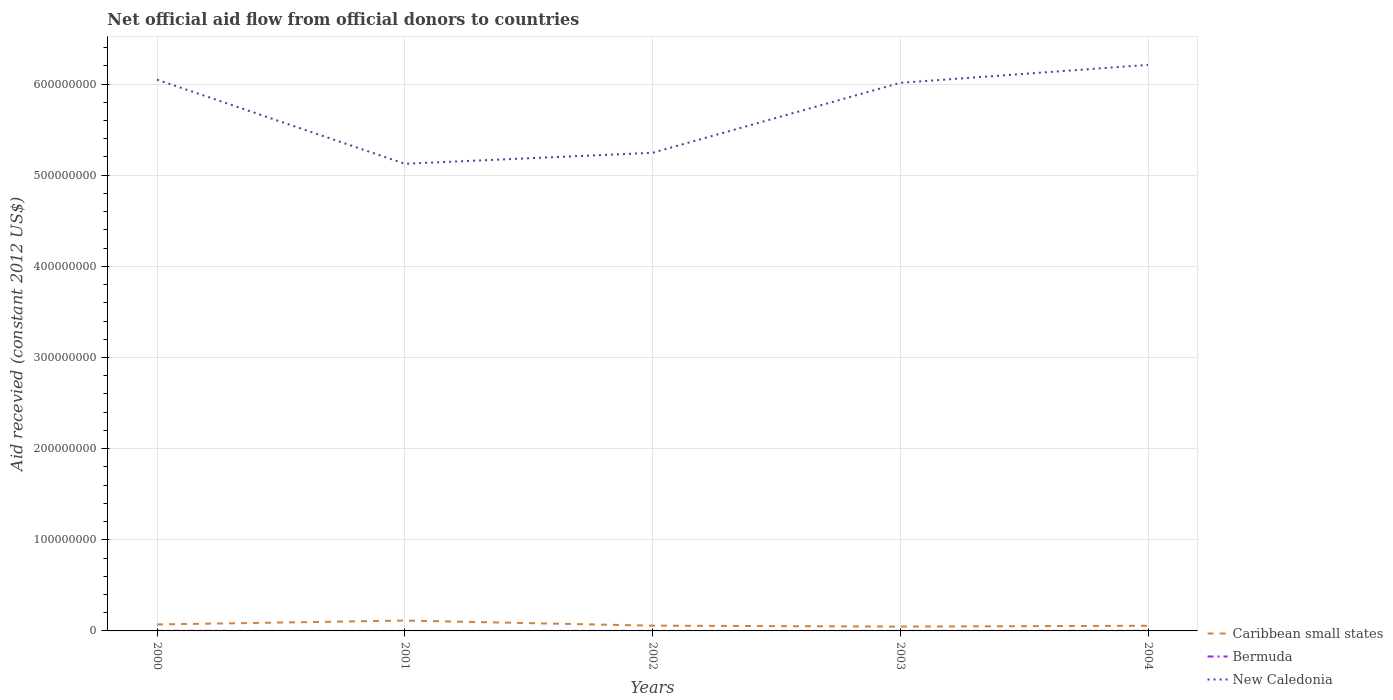Is the number of lines equal to the number of legend labels?
Give a very brief answer. Yes. Across all years, what is the maximum total aid received in Bermuda?
Give a very brief answer. 3.00e+04. What is the total total aid received in Bermuda in the graph?
Offer a very short reply. -8.00e+04. What is the difference between the highest and the second highest total aid received in Caribbean small states?
Ensure brevity in your answer.  6.62e+06. What is the difference between the highest and the lowest total aid received in Caribbean small states?
Offer a very short reply. 2. How many lines are there?
Ensure brevity in your answer.  3. Where does the legend appear in the graph?
Offer a terse response. Bottom right. How many legend labels are there?
Your response must be concise. 3. How are the legend labels stacked?
Provide a short and direct response. Vertical. What is the title of the graph?
Keep it short and to the point. Net official aid flow from official donors to countries. What is the label or title of the X-axis?
Ensure brevity in your answer.  Years. What is the label or title of the Y-axis?
Ensure brevity in your answer.  Aid recevied (constant 2012 US$). What is the Aid recevied (constant 2012 US$) in Caribbean small states in 2000?
Provide a succinct answer. 7.08e+06. What is the Aid recevied (constant 2012 US$) of New Caledonia in 2000?
Keep it short and to the point. 6.05e+08. What is the Aid recevied (constant 2012 US$) of Caribbean small states in 2001?
Ensure brevity in your answer.  1.14e+07. What is the Aid recevied (constant 2012 US$) of New Caledonia in 2001?
Make the answer very short. 5.13e+08. What is the Aid recevied (constant 2012 US$) in Caribbean small states in 2002?
Give a very brief answer. 5.78e+06. What is the Aid recevied (constant 2012 US$) in New Caledonia in 2002?
Provide a short and direct response. 5.25e+08. What is the Aid recevied (constant 2012 US$) in Caribbean small states in 2003?
Ensure brevity in your answer.  4.76e+06. What is the Aid recevied (constant 2012 US$) of New Caledonia in 2003?
Give a very brief answer. 6.01e+08. What is the Aid recevied (constant 2012 US$) in Caribbean small states in 2004?
Make the answer very short. 5.66e+06. What is the Aid recevied (constant 2012 US$) in Bermuda in 2004?
Give a very brief answer. 1.10e+05. What is the Aid recevied (constant 2012 US$) in New Caledonia in 2004?
Offer a very short reply. 6.21e+08. Across all years, what is the maximum Aid recevied (constant 2012 US$) in Caribbean small states?
Your response must be concise. 1.14e+07. Across all years, what is the maximum Aid recevied (constant 2012 US$) of New Caledonia?
Keep it short and to the point. 6.21e+08. Across all years, what is the minimum Aid recevied (constant 2012 US$) in Caribbean small states?
Provide a short and direct response. 4.76e+06. Across all years, what is the minimum Aid recevied (constant 2012 US$) of Bermuda?
Keep it short and to the point. 3.00e+04. Across all years, what is the minimum Aid recevied (constant 2012 US$) in New Caledonia?
Your answer should be very brief. 5.13e+08. What is the total Aid recevied (constant 2012 US$) of Caribbean small states in the graph?
Keep it short and to the point. 3.47e+07. What is the total Aid recevied (constant 2012 US$) in New Caledonia in the graph?
Make the answer very short. 2.86e+09. What is the difference between the Aid recevied (constant 2012 US$) of Caribbean small states in 2000 and that in 2001?
Give a very brief answer. -4.30e+06. What is the difference between the Aid recevied (constant 2012 US$) in New Caledonia in 2000 and that in 2001?
Provide a short and direct response. 9.23e+07. What is the difference between the Aid recevied (constant 2012 US$) in Caribbean small states in 2000 and that in 2002?
Ensure brevity in your answer.  1.30e+06. What is the difference between the Aid recevied (constant 2012 US$) in Bermuda in 2000 and that in 2002?
Make the answer very short. 8.00e+04. What is the difference between the Aid recevied (constant 2012 US$) of New Caledonia in 2000 and that in 2002?
Your answer should be compact. 8.02e+07. What is the difference between the Aid recevied (constant 2012 US$) of Caribbean small states in 2000 and that in 2003?
Provide a succinct answer. 2.32e+06. What is the difference between the Aid recevied (constant 2012 US$) in New Caledonia in 2000 and that in 2003?
Give a very brief answer. 3.50e+06. What is the difference between the Aid recevied (constant 2012 US$) of Caribbean small states in 2000 and that in 2004?
Offer a very short reply. 1.42e+06. What is the difference between the Aid recevied (constant 2012 US$) of Bermuda in 2000 and that in 2004?
Provide a short and direct response. 0. What is the difference between the Aid recevied (constant 2012 US$) in New Caledonia in 2000 and that in 2004?
Provide a short and direct response. -1.62e+07. What is the difference between the Aid recevied (constant 2012 US$) of Caribbean small states in 2001 and that in 2002?
Keep it short and to the point. 5.60e+06. What is the difference between the Aid recevied (constant 2012 US$) in Bermuda in 2001 and that in 2002?
Your answer should be very brief. 10000. What is the difference between the Aid recevied (constant 2012 US$) in New Caledonia in 2001 and that in 2002?
Offer a very short reply. -1.21e+07. What is the difference between the Aid recevied (constant 2012 US$) of Caribbean small states in 2001 and that in 2003?
Ensure brevity in your answer.  6.62e+06. What is the difference between the Aid recevied (constant 2012 US$) of New Caledonia in 2001 and that in 2003?
Provide a succinct answer. -8.88e+07. What is the difference between the Aid recevied (constant 2012 US$) of Caribbean small states in 2001 and that in 2004?
Offer a terse response. 5.72e+06. What is the difference between the Aid recevied (constant 2012 US$) of Bermuda in 2001 and that in 2004?
Offer a very short reply. -7.00e+04. What is the difference between the Aid recevied (constant 2012 US$) of New Caledonia in 2001 and that in 2004?
Give a very brief answer. -1.08e+08. What is the difference between the Aid recevied (constant 2012 US$) of Caribbean small states in 2002 and that in 2003?
Offer a terse response. 1.02e+06. What is the difference between the Aid recevied (constant 2012 US$) of New Caledonia in 2002 and that in 2003?
Keep it short and to the point. -7.67e+07. What is the difference between the Aid recevied (constant 2012 US$) of New Caledonia in 2002 and that in 2004?
Provide a succinct answer. -9.64e+07. What is the difference between the Aid recevied (constant 2012 US$) of Caribbean small states in 2003 and that in 2004?
Provide a short and direct response. -9.00e+05. What is the difference between the Aid recevied (constant 2012 US$) in New Caledonia in 2003 and that in 2004?
Give a very brief answer. -1.97e+07. What is the difference between the Aid recevied (constant 2012 US$) in Caribbean small states in 2000 and the Aid recevied (constant 2012 US$) in Bermuda in 2001?
Provide a short and direct response. 7.04e+06. What is the difference between the Aid recevied (constant 2012 US$) of Caribbean small states in 2000 and the Aid recevied (constant 2012 US$) of New Caledonia in 2001?
Offer a terse response. -5.05e+08. What is the difference between the Aid recevied (constant 2012 US$) of Bermuda in 2000 and the Aid recevied (constant 2012 US$) of New Caledonia in 2001?
Keep it short and to the point. -5.12e+08. What is the difference between the Aid recevied (constant 2012 US$) of Caribbean small states in 2000 and the Aid recevied (constant 2012 US$) of Bermuda in 2002?
Provide a short and direct response. 7.05e+06. What is the difference between the Aid recevied (constant 2012 US$) in Caribbean small states in 2000 and the Aid recevied (constant 2012 US$) in New Caledonia in 2002?
Your response must be concise. -5.18e+08. What is the difference between the Aid recevied (constant 2012 US$) of Bermuda in 2000 and the Aid recevied (constant 2012 US$) of New Caledonia in 2002?
Provide a succinct answer. -5.24e+08. What is the difference between the Aid recevied (constant 2012 US$) of Caribbean small states in 2000 and the Aid recevied (constant 2012 US$) of Bermuda in 2003?
Make the answer very short. 7.04e+06. What is the difference between the Aid recevied (constant 2012 US$) in Caribbean small states in 2000 and the Aid recevied (constant 2012 US$) in New Caledonia in 2003?
Offer a very short reply. -5.94e+08. What is the difference between the Aid recevied (constant 2012 US$) in Bermuda in 2000 and the Aid recevied (constant 2012 US$) in New Caledonia in 2003?
Ensure brevity in your answer.  -6.01e+08. What is the difference between the Aid recevied (constant 2012 US$) in Caribbean small states in 2000 and the Aid recevied (constant 2012 US$) in Bermuda in 2004?
Ensure brevity in your answer.  6.97e+06. What is the difference between the Aid recevied (constant 2012 US$) of Caribbean small states in 2000 and the Aid recevied (constant 2012 US$) of New Caledonia in 2004?
Provide a short and direct response. -6.14e+08. What is the difference between the Aid recevied (constant 2012 US$) in Bermuda in 2000 and the Aid recevied (constant 2012 US$) in New Caledonia in 2004?
Make the answer very short. -6.21e+08. What is the difference between the Aid recevied (constant 2012 US$) of Caribbean small states in 2001 and the Aid recevied (constant 2012 US$) of Bermuda in 2002?
Provide a succinct answer. 1.14e+07. What is the difference between the Aid recevied (constant 2012 US$) in Caribbean small states in 2001 and the Aid recevied (constant 2012 US$) in New Caledonia in 2002?
Your answer should be compact. -5.13e+08. What is the difference between the Aid recevied (constant 2012 US$) in Bermuda in 2001 and the Aid recevied (constant 2012 US$) in New Caledonia in 2002?
Ensure brevity in your answer.  -5.25e+08. What is the difference between the Aid recevied (constant 2012 US$) of Caribbean small states in 2001 and the Aid recevied (constant 2012 US$) of Bermuda in 2003?
Your answer should be very brief. 1.13e+07. What is the difference between the Aid recevied (constant 2012 US$) in Caribbean small states in 2001 and the Aid recevied (constant 2012 US$) in New Caledonia in 2003?
Provide a succinct answer. -5.90e+08. What is the difference between the Aid recevied (constant 2012 US$) of Bermuda in 2001 and the Aid recevied (constant 2012 US$) of New Caledonia in 2003?
Offer a terse response. -6.01e+08. What is the difference between the Aid recevied (constant 2012 US$) in Caribbean small states in 2001 and the Aid recevied (constant 2012 US$) in Bermuda in 2004?
Your response must be concise. 1.13e+07. What is the difference between the Aid recevied (constant 2012 US$) in Caribbean small states in 2001 and the Aid recevied (constant 2012 US$) in New Caledonia in 2004?
Provide a succinct answer. -6.10e+08. What is the difference between the Aid recevied (constant 2012 US$) of Bermuda in 2001 and the Aid recevied (constant 2012 US$) of New Caledonia in 2004?
Make the answer very short. -6.21e+08. What is the difference between the Aid recevied (constant 2012 US$) in Caribbean small states in 2002 and the Aid recevied (constant 2012 US$) in Bermuda in 2003?
Your answer should be very brief. 5.74e+06. What is the difference between the Aid recevied (constant 2012 US$) of Caribbean small states in 2002 and the Aid recevied (constant 2012 US$) of New Caledonia in 2003?
Your answer should be very brief. -5.96e+08. What is the difference between the Aid recevied (constant 2012 US$) of Bermuda in 2002 and the Aid recevied (constant 2012 US$) of New Caledonia in 2003?
Provide a short and direct response. -6.01e+08. What is the difference between the Aid recevied (constant 2012 US$) in Caribbean small states in 2002 and the Aid recevied (constant 2012 US$) in Bermuda in 2004?
Make the answer very short. 5.67e+06. What is the difference between the Aid recevied (constant 2012 US$) in Caribbean small states in 2002 and the Aid recevied (constant 2012 US$) in New Caledonia in 2004?
Provide a succinct answer. -6.15e+08. What is the difference between the Aid recevied (constant 2012 US$) in Bermuda in 2002 and the Aid recevied (constant 2012 US$) in New Caledonia in 2004?
Provide a short and direct response. -6.21e+08. What is the difference between the Aid recevied (constant 2012 US$) of Caribbean small states in 2003 and the Aid recevied (constant 2012 US$) of Bermuda in 2004?
Provide a short and direct response. 4.65e+06. What is the difference between the Aid recevied (constant 2012 US$) of Caribbean small states in 2003 and the Aid recevied (constant 2012 US$) of New Caledonia in 2004?
Provide a succinct answer. -6.16e+08. What is the difference between the Aid recevied (constant 2012 US$) in Bermuda in 2003 and the Aid recevied (constant 2012 US$) in New Caledonia in 2004?
Your answer should be compact. -6.21e+08. What is the average Aid recevied (constant 2012 US$) in Caribbean small states per year?
Make the answer very short. 6.93e+06. What is the average Aid recevied (constant 2012 US$) of Bermuda per year?
Ensure brevity in your answer.  6.60e+04. What is the average Aid recevied (constant 2012 US$) of New Caledonia per year?
Provide a succinct answer. 5.73e+08. In the year 2000, what is the difference between the Aid recevied (constant 2012 US$) in Caribbean small states and Aid recevied (constant 2012 US$) in Bermuda?
Ensure brevity in your answer.  6.97e+06. In the year 2000, what is the difference between the Aid recevied (constant 2012 US$) of Caribbean small states and Aid recevied (constant 2012 US$) of New Caledonia?
Provide a succinct answer. -5.98e+08. In the year 2000, what is the difference between the Aid recevied (constant 2012 US$) in Bermuda and Aid recevied (constant 2012 US$) in New Caledonia?
Give a very brief answer. -6.05e+08. In the year 2001, what is the difference between the Aid recevied (constant 2012 US$) in Caribbean small states and Aid recevied (constant 2012 US$) in Bermuda?
Provide a succinct answer. 1.13e+07. In the year 2001, what is the difference between the Aid recevied (constant 2012 US$) of Caribbean small states and Aid recevied (constant 2012 US$) of New Caledonia?
Give a very brief answer. -5.01e+08. In the year 2001, what is the difference between the Aid recevied (constant 2012 US$) in Bermuda and Aid recevied (constant 2012 US$) in New Caledonia?
Offer a terse response. -5.12e+08. In the year 2002, what is the difference between the Aid recevied (constant 2012 US$) in Caribbean small states and Aid recevied (constant 2012 US$) in Bermuda?
Ensure brevity in your answer.  5.75e+06. In the year 2002, what is the difference between the Aid recevied (constant 2012 US$) of Caribbean small states and Aid recevied (constant 2012 US$) of New Caledonia?
Offer a very short reply. -5.19e+08. In the year 2002, what is the difference between the Aid recevied (constant 2012 US$) in Bermuda and Aid recevied (constant 2012 US$) in New Caledonia?
Your answer should be compact. -5.25e+08. In the year 2003, what is the difference between the Aid recevied (constant 2012 US$) in Caribbean small states and Aid recevied (constant 2012 US$) in Bermuda?
Your answer should be compact. 4.72e+06. In the year 2003, what is the difference between the Aid recevied (constant 2012 US$) in Caribbean small states and Aid recevied (constant 2012 US$) in New Caledonia?
Your answer should be very brief. -5.97e+08. In the year 2003, what is the difference between the Aid recevied (constant 2012 US$) of Bermuda and Aid recevied (constant 2012 US$) of New Caledonia?
Provide a succinct answer. -6.01e+08. In the year 2004, what is the difference between the Aid recevied (constant 2012 US$) in Caribbean small states and Aid recevied (constant 2012 US$) in Bermuda?
Provide a short and direct response. 5.55e+06. In the year 2004, what is the difference between the Aid recevied (constant 2012 US$) of Caribbean small states and Aid recevied (constant 2012 US$) of New Caledonia?
Keep it short and to the point. -6.15e+08. In the year 2004, what is the difference between the Aid recevied (constant 2012 US$) of Bermuda and Aid recevied (constant 2012 US$) of New Caledonia?
Make the answer very short. -6.21e+08. What is the ratio of the Aid recevied (constant 2012 US$) in Caribbean small states in 2000 to that in 2001?
Provide a succinct answer. 0.62. What is the ratio of the Aid recevied (constant 2012 US$) of Bermuda in 2000 to that in 2001?
Provide a short and direct response. 2.75. What is the ratio of the Aid recevied (constant 2012 US$) in New Caledonia in 2000 to that in 2001?
Ensure brevity in your answer.  1.18. What is the ratio of the Aid recevied (constant 2012 US$) of Caribbean small states in 2000 to that in 2002?
Offer a very short reply. 1.22. What is the ratio of the Aid recevied (constant 2012 US$) in Bermuda in 2000 to that in 2002?
Provide a short and direct response. 3.67. What is the ratio of the Aid recevied (constant 2012 US$) of New Caledonia in 2000 to that in 2002?
Provide a short and direct response. 1.15. What is the ratio of the Aid recevied (constant 2012 US$) of Caribbean small states in 2000 to that in 2003?
Offer a very short reply. 1.49. What is the ratio of the Aid recevied (constant 2012 US$) of Bermuda in 2000 to that in 2003?
Ensure brevity in your answer.  2.75. What is the ratio of the Aid recevied (constant 2012 US$) of New Caledonia in 2000 to that in 2003?
Ensure brevity in your answer.  1.01. What is the ratio of the Aid recevied (constant 2012 US$) in Caribbean small states in 2000 to that in 2004?
Provide a short and direct response. 1.25. What is the ratio of the Aid recevied (constant 2012 US$) in New Caledonia in 2000 to that in 2004?
Your response must be concise. 0.97. What is the ratio of the Aid recevied (constant 2012 US$) in Caribbean small states in 2001 to that in 2002?
Make the answer very short. 1.97. What is the ratio of the Aid recevied (constant 2012 US$) in New Caledonia in 2001 to that in 2002?
Your answer should be very brief. 0.98. What is the ratio of the Aid recevied (constant 2012 US$) of Caribbean small states in 2001 to that in 2003?
Ensure brevity in your answer.  2.39. What is the ratio of the Aid recevied (constant 2012 US$) of Bermuda in 2001 to that in 2003?
Provide a succinct answer. 1. What is the ratio of the Aid recevied (constant 2012 US$) in New Caledonia in 2001 to that in 2003?
Offer a terse response. 0.85. What is the ratio of the Aid recevied (constant 2012 US$) of Caribbean small states in 2001 to that in 2004?
Provide a short and direct response. 2.01. What is the ratio of the Aid recevied (constant 2012 US$) of Bermuda in 2001 to that in 2004?
Provide a succinct answer. 0.36. What is the ratio of the Aid recevied (constant 2012 US$) of New Caledonia in 2001 to that in 2004?
Offer a very short reply. 0.83. What is the ratio of the Aid recevied (constant 2012 US$) of Caribbean small states in 2002 to that in 2003?
Offer a terse response. 1.21. What is the ratio of the Aid recevied (constant 2012 US$) in New Caledonia in 2002 to that in 2003?
Offer a very short reply. 0.87. What is the ratio of the Aid recevied (constant 2012 US$) in Caribbean small states in 2002 to that in 2004?
Provide a succinct answer. 1.02. What is the ratio of the Aid recevied (constant 2012 US$) of Bermuda in 2002 to that in 2004?
Keep it short and to the point. 0.27. What is the ratio of the Aid recevied (constant 2012 US$) of New Caledonia in 2002 to that in 2004?
Offer a terse response. 0.84. What is the ratio of the Aid recevied (constant 2012 US$) of Caribbean small states in 2003 to that in 2004?
Ensure brevity in your answer.  0.84. What is the ratio of the Aid recevied (constant 2012 US$) of Bermuda in 2003 to that in 2004?
Provide a short and direct response. 0.36. What is the ratio of the Aid recevied (constant 2012 US$) in New Caledonia in 2003 to that in 2004?
Your answer should be very brief. 0.97. What is the difference between the highest and the second highest Aid recevied (constant 2012 US$) of Caribbean small states?
Provide a short and direct response. 4.30e+06. What is the difference between the highest and the second highest Aid recevied (constant 2012 US$) of Bermuda?
Your answer should be very brief. 0. What is the difference between the highest and the second highest Aid recevied (constant 2012 US$) in New Caledonia?
Offer a terse response. 1.62e+07. What is the difference between the highest and the lowest Aid recevied (constant 2012 US$) in Caribbean small states?
Keep it short and to the point. 6.62e+06. What is the difference between the highest and the lowest Aid recevied (constant 2012 US$) of Bermuda?
Provide a succinct answer. 8.00e+04. What is the difference between the highest and the lowest Aid recevied (constant 2012 US$) of New Caledonia?
Give a very brief answer. 1.08e+08. 